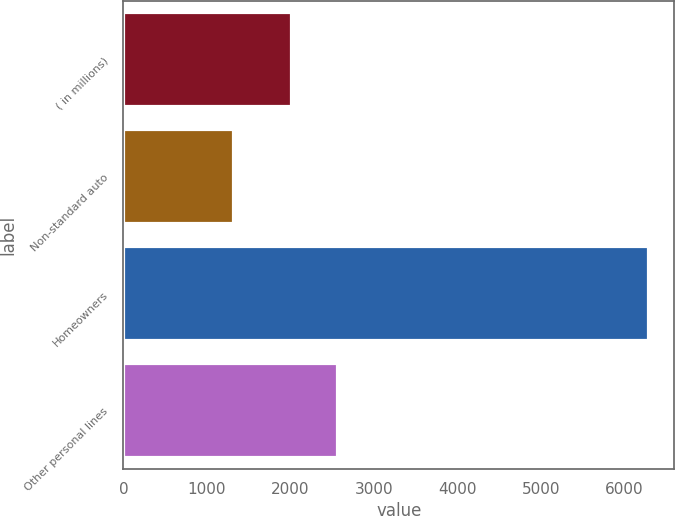Convert chart. <chart><loc_0><loc_0><loc_500><loc_500><bar_chart><fcel>( in millions)<fcel>Non-standard auto<fcel>Homeowners<fcel>Other personal lines<nl><fcel>2007<fcel>1308<fcel>6283<fcel>2562<nl></chart> 